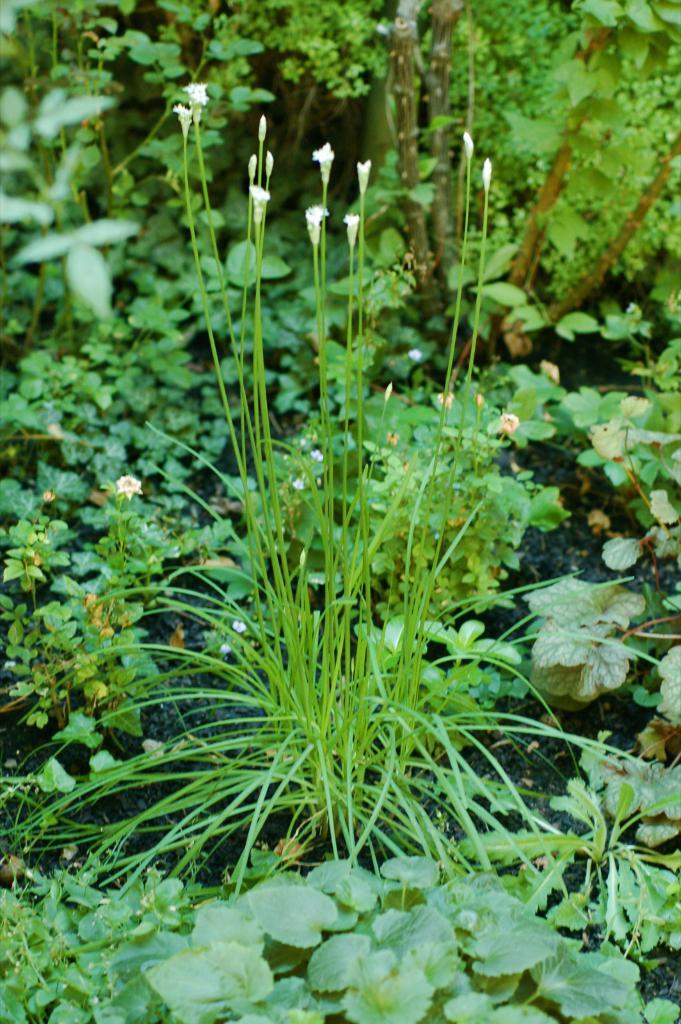What type of flowers can be seen in the image? There are white flowers in the image. Where are the flowers located? The flowers are on trees in the image. What other types of vegetation are present in the image? There are trees and plants in the image. How many brothers are playing with the rabbits in the image? There are no brothers or rabbits present in the image; it features white flowers on trees. 